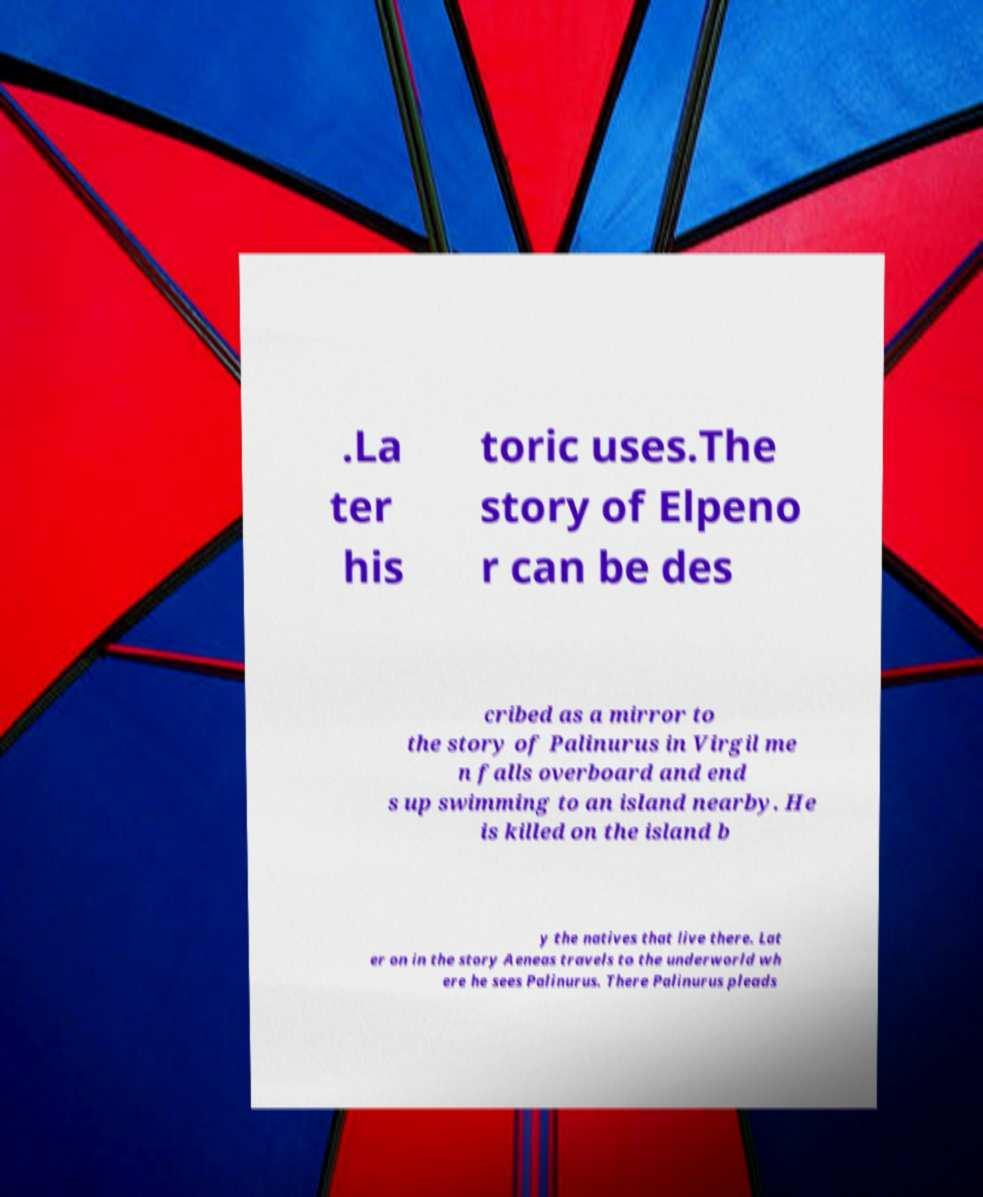What messages or text are displayed in this image? I need them in a readable, typed format. .La ter his toric uses.The story of Elpeno r can be des cribed as a mirror to the story of Palinurus in Virgil me n falls overboard and end s up swimming to an island nearby. He is killed on the island b y the natives that live there. Lat er on in the story Aeneas travels to the underworld wh ere he sees Palinurus. There Palinurus pleads 